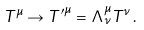<formula> <loc_0><loc_0><loc_500><loc_500>T ^ { \mu } \rightarrow { T ^ { \prime } } ^ { \mu } = \Lambda ^ { \mu } _ { \nu } T ^ { \nu } \, .</formula> 